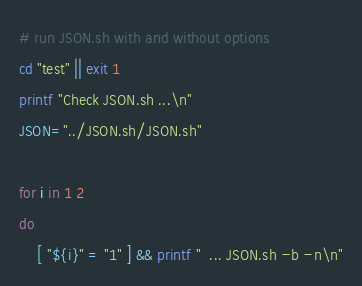<code> <loc_0><loc_0><loc_500><loc_500><_Bash_>
# run JSON.sh with and without options
cd "test" || exit 1
printf "Check JSON.sh ...\n"
JSON="../JSON.sh/JSON.sh"

for i in 1 2
do
    [ "${i}" = "1" ] && printf "  ... JSON.sh -b -n\n"</code> 